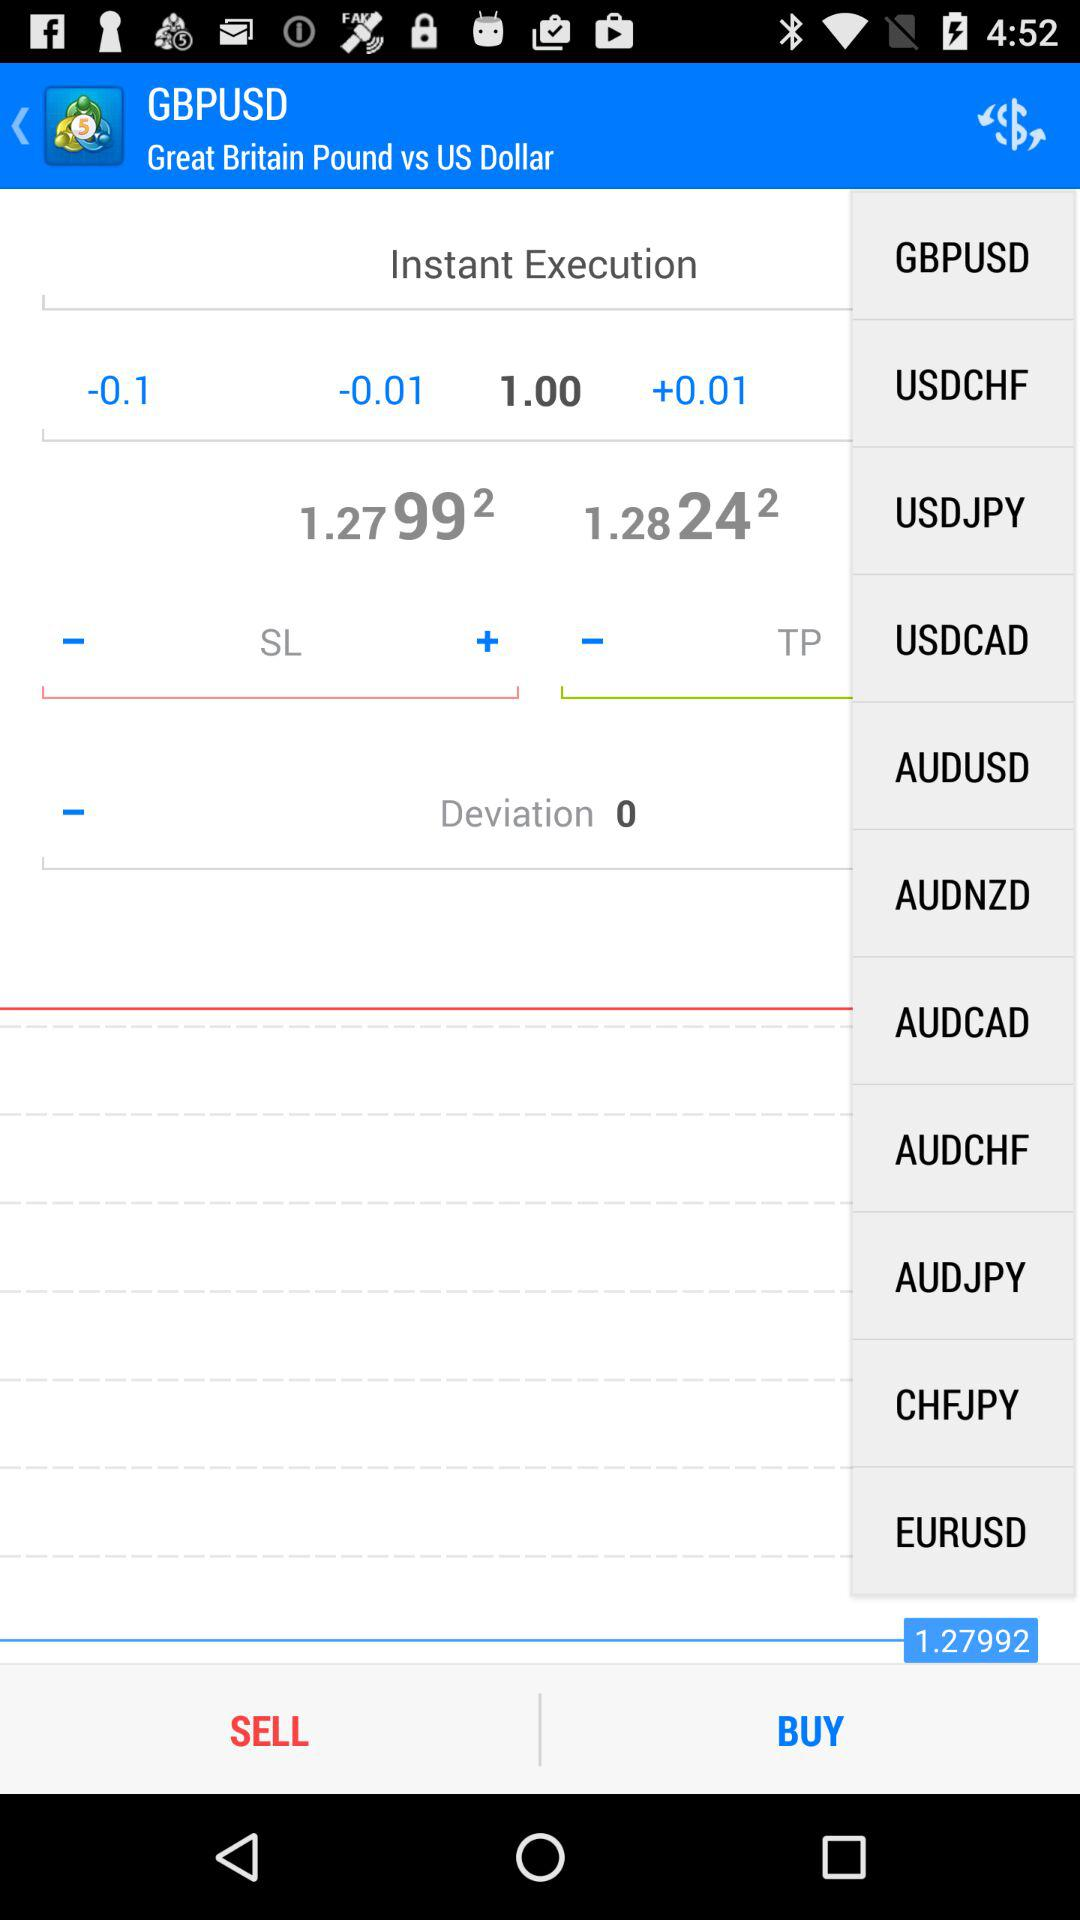What is the value of the deviation?
Answer the question using a single word or phrase. 0 